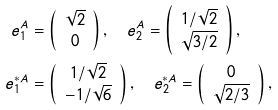Convert formula to latex. <formula><loc_0><loc_0><loc_500><loc_500>e ^ { A } _ { 1 } & = \left ( \begin{array} { c } \sqrt { 2 } \\ 0 \end{array} \right ) , \quad e ^ { A } _ { 2 } = \left ( \begin{array} { c } 1 / \sqrt { 2 } \\ \sqrt { 3 / 2 } \end{array} \right ) , \\ e ^ { \ast { A } } _ { 1 } & = \left ( \begin{array} { c } 1 / \sqrt { 2 } \\ - 1 / \sqrt { 6 } \end{array} \right ) , \quad e ^ { \ast { A } } _ { 2 } = \left ( \begin{array} { c } 0 \\ \sqrt { 2 / 3 } \end{array} \right ) ,</formula> 